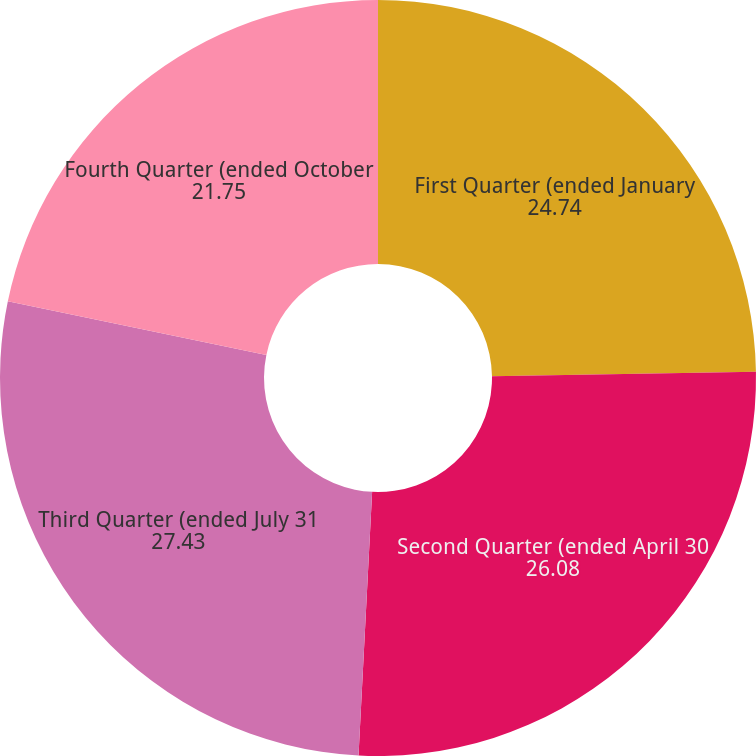<chart> <loc_0><loc_0><loc_500><loc_500><pie_chart><fcel>First Quarter (ended January<fcel>Second Quarter (ended April 30<fcel>Third Quarter (ended July 31<fcel>Fourth Quarter (ended October<nl><fcel>24.74%<fcel>26.08%<fcel>27.43%<fcel>21.75%<nl></chart> 